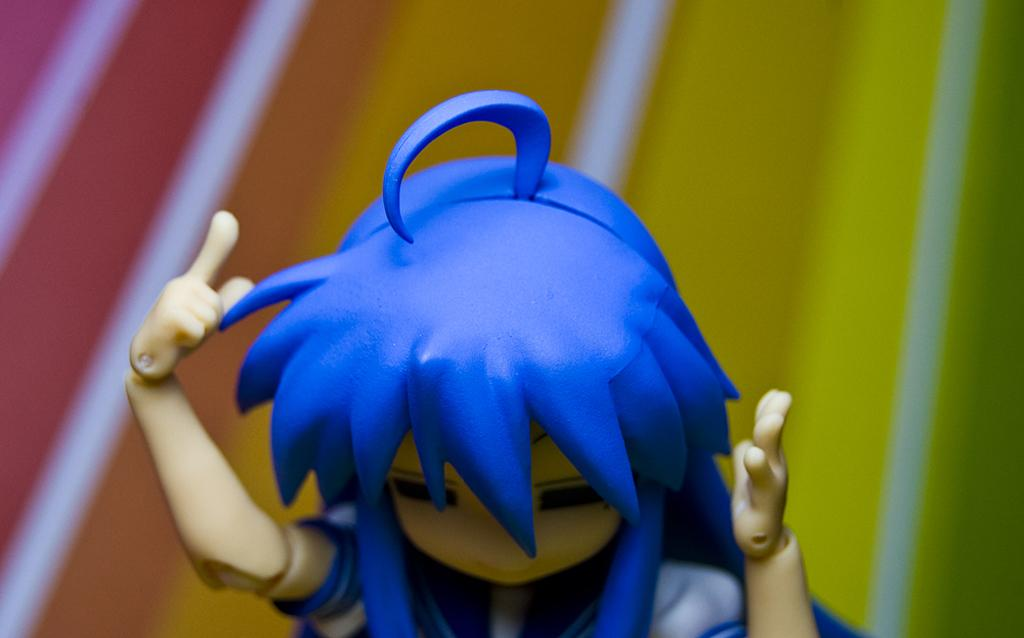What object can be seen in the image that is not a part of the natural environment? There is a toy in the image. Can you describe the colors that are visible in the image? There are multiple colors visible in the image. What type of jeans is the toy wearing in the image? The toy is not wearing jeans, as it is not a person or an object that typically wears clothing. 